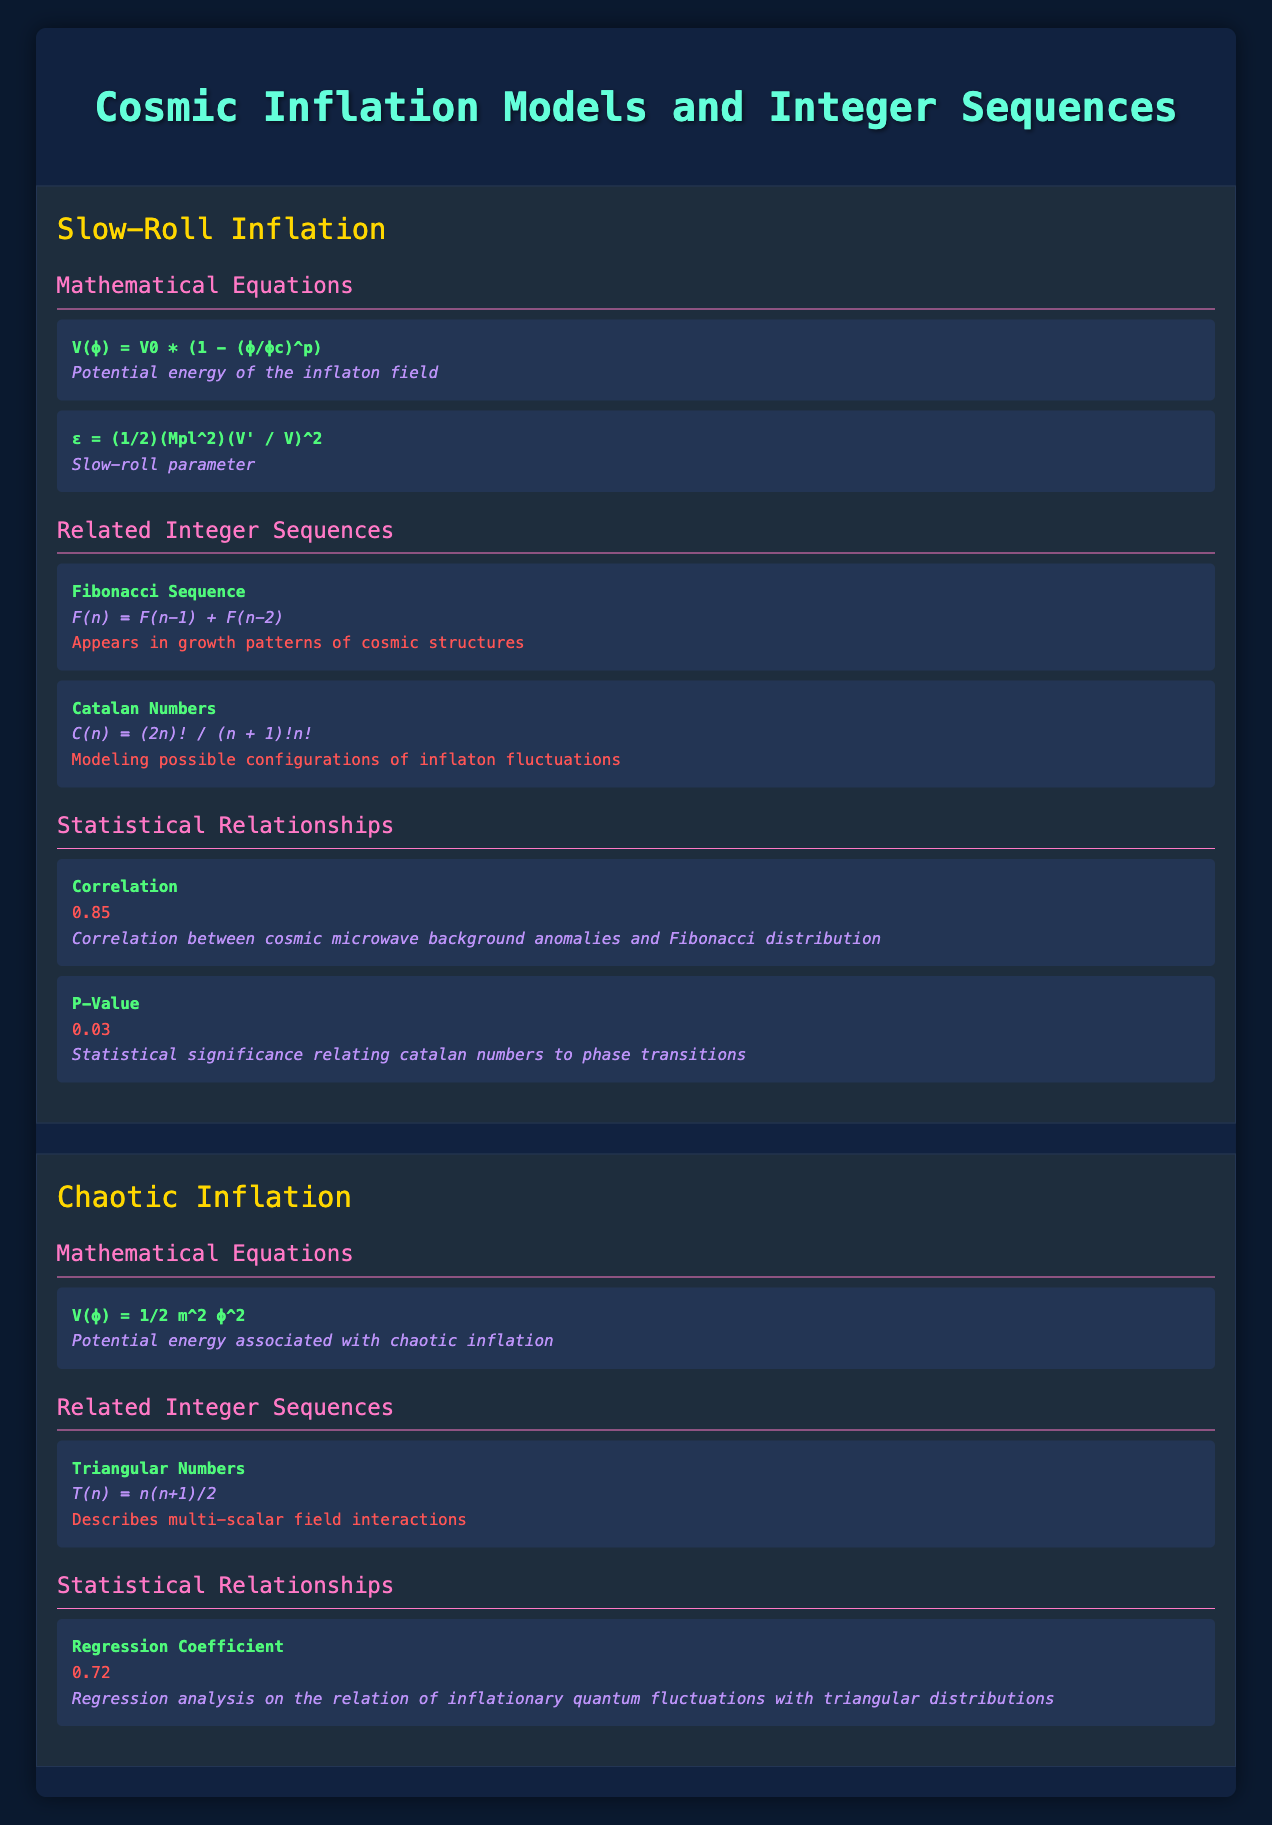What is the correlation value between cosmic microwave background anomalies and Fibonacci distribution? The correlation value mentioned in the table under "Statistical Relationships" for the Slow-Roll Inflation model is 0.85.
Answer: 0.85 What is the equation for the potential energy associated with chaotic inflation? The table lists one mathematical equation for the Chaotic Inflation model: V(ϕ) = 1/2 m^2 ϕ^2, which describes the potential energy.
Answer: V(ϕ) = 1/2 m^2 ϕ^2 True or False: The Fibonacci sequence is related to the chaotic inflation model. The table lists the Fibonacci sequence only under the Slow-Roll Inflation model, indicating it is not related to the Chaotic Inflation model.
Answer: False What is the P-Value concerning the Catalan numbers? The table specifies a P-Value of 0.03 relating to the statistical significance of the Catalan numbers and phase transitions in the Slow-Roll Inflation model.
Answer: 0.03 Which integer sequence describes multi-scalar field interactions? According to the table, the triangular numbers are the sequence that describes multi-scalar field interactions, listed under the Chaotic Inflation model.
Answer: Triangular Numbers What is the regression coefficient for inflationary quantum fluctuations with triangular distributions? In the table, the regression coefficient specified for this relationship under the Chaotic Inflation model is 0.72.
Answer: 0.72 True or False: The Catalan numbers are connected to growth patterns of cosmic structures. The table shows that the Catalan numbers are connected to modeling possible configurations of inflaton fluctuations, indicating they are not related to growth patterns of cosmic structures.
Answer: False What is the statistical significance for the correlation between cosmic microwave background anomalies and Fibonacci distribution based on the correlation value? The correlation value (0.85) suggests a strong relationship, but to claim statistical significance, we need to consider the p-value as well, which is not directly applicable here, only a correlation value was given. Thus, we can conclude about the strength but not significance without a p-value.
Answer: 0.85 suggests strong correlation but p-value needed for significance What are the connections of the Fibonacci Sequence in the context of cosmic inflation models? The table indicates that the Fibonacci sequence, defined by F(n) = F(n-1) + F(n-2), appears in growth patterns of cosmic structures, specifically under the Slow-Roll Inflation model.
Answer: Appears in growth patterns of cosmic structures 